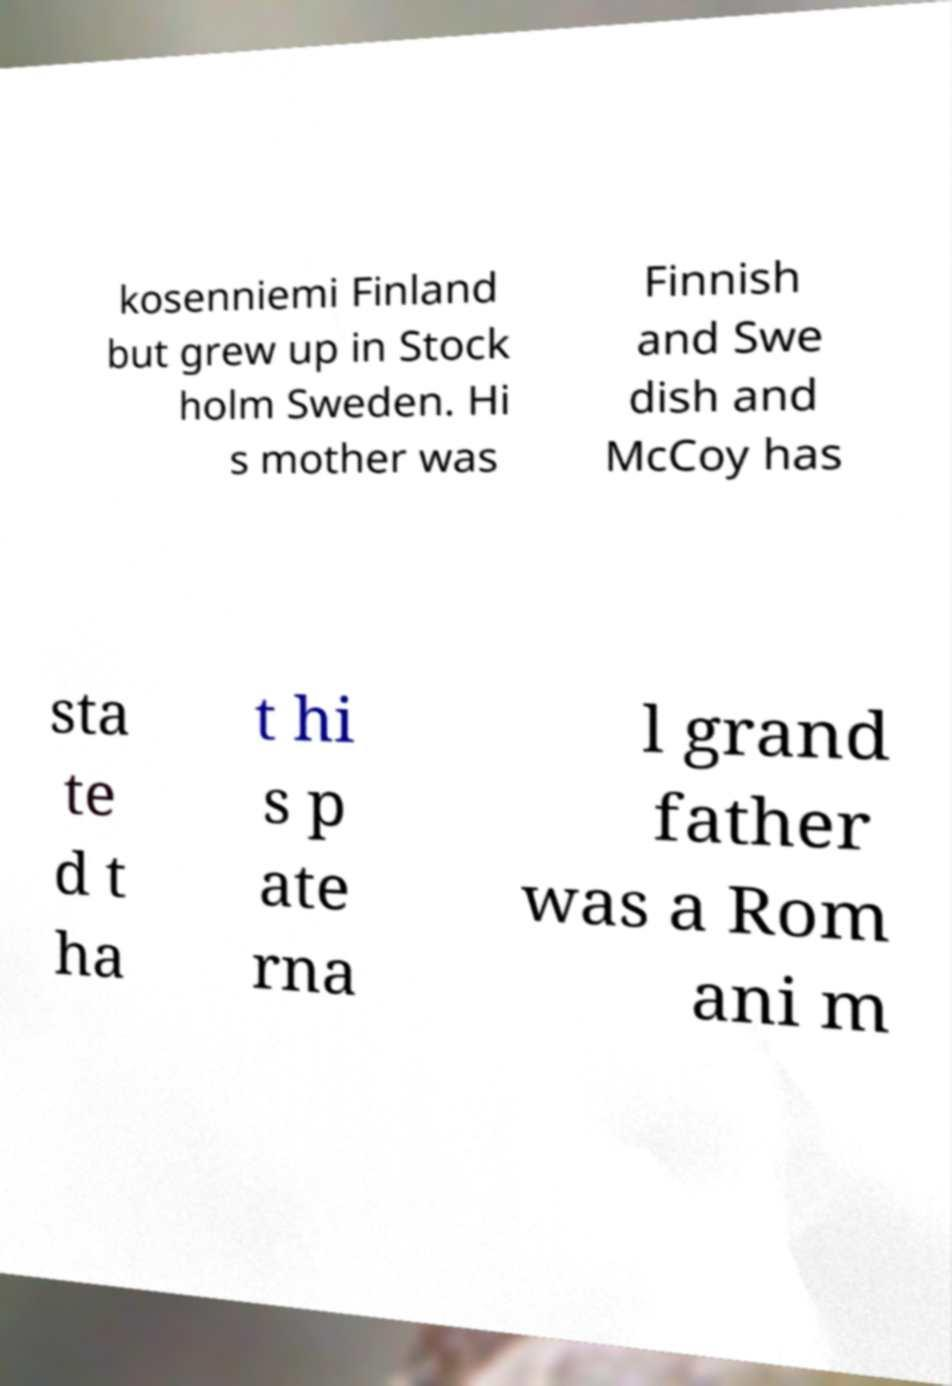What messages or text are displayed in this image? I need them in a readable, typed format. kosenniemi Finland but grew up in Stock holm Sweden. Hi s mother was Finnish and Swe dish and McCoy has sta te d t ha t hi s p ate rna l grand father was a Rom ani m 